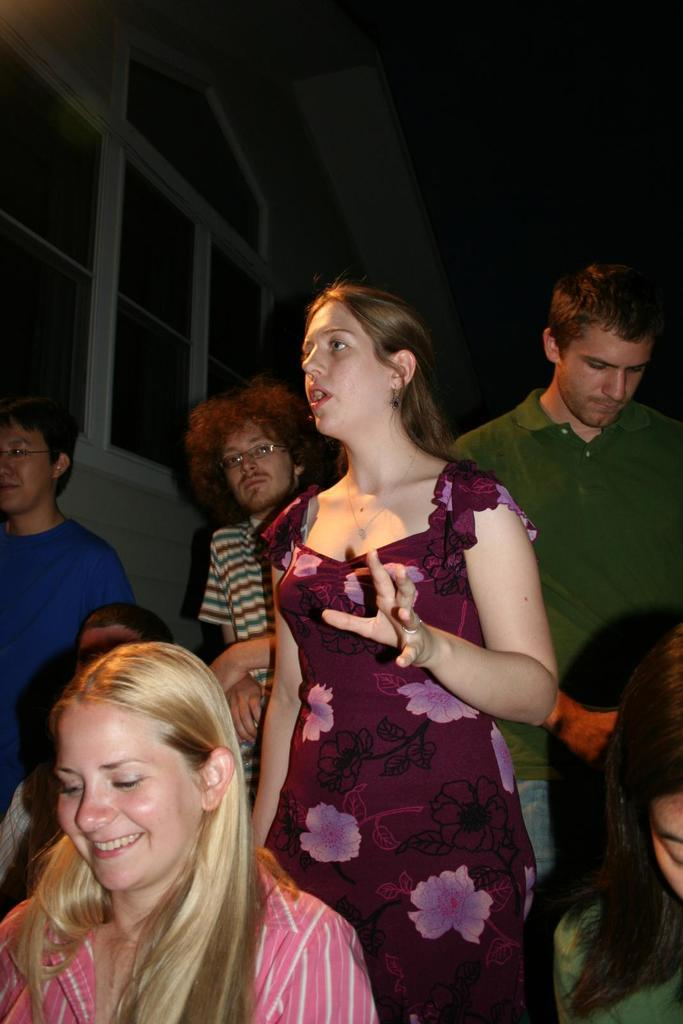What is happening in the image? There is a group of people in the image. Can you describe the expressions or actions of the people in the image? A woman in the front is smiling, and a woman in the middle is speaking. What type of throat system does the woman in the middle have? There is no information about the woman's throat system in the image, as the focus is on her speaking. 